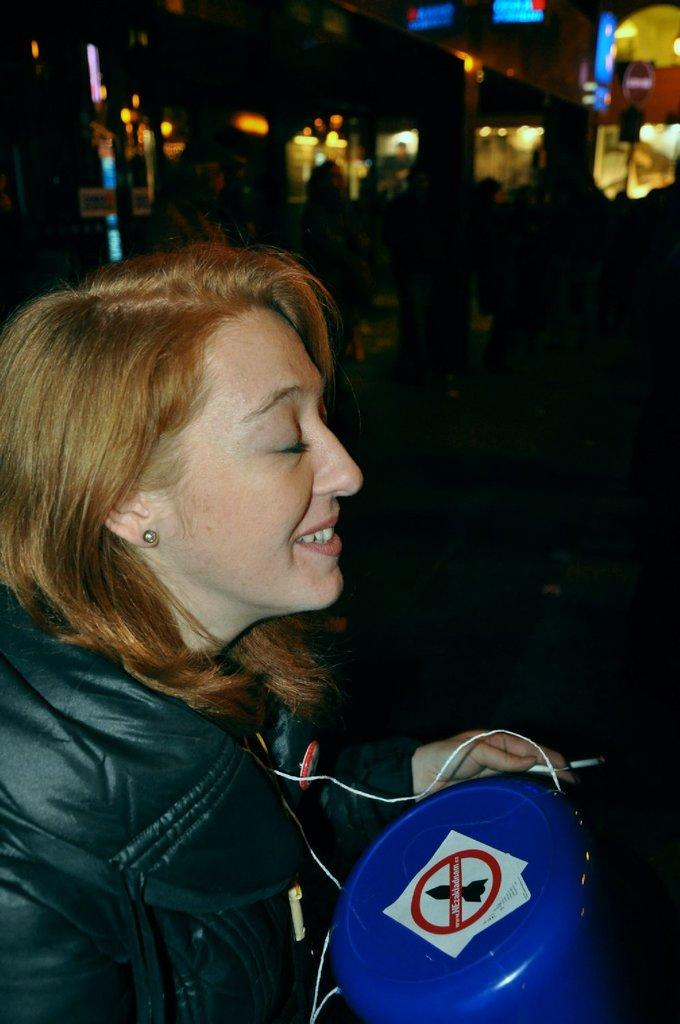Who is present in the image? There is a woman in the image. What is the woman wearing? The woman is wearing a black jacket. What is the woman holding in the image? The woman is holding something. What type of flesh can be seen on the woman's face in the image? There is no flesh visible on the woman's face in the image; it is not possible to determine the texture or appearance of her skin from the provided facts. 